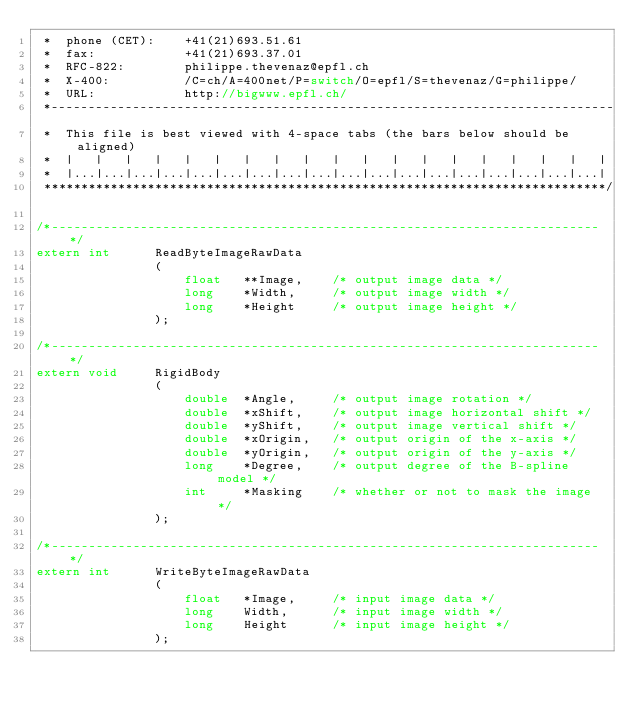Convert code to text. <code><loc_0><loc_0><loc_500><loc_500><_C_> *	phone (CET):	+41(21)693.51.61
 *	fax:			+41(21)693.37.01
 *	RFC-822:		philippe.thevenaz@epfl.ch
 *	X-400:			/C=ch/A=400net/P=switch/O=epfl/S=thevenaz/G=philippe/
 *	URL:			http://bigwww.epfl.ch/
 *----------------------------------------------------------------------------
 *	This file is best viewed with 4-space tabs (the bars below should be aligned)
 *	|	|	|	|	|	|	|	|	|	|	|	|	|	|	|	|	|	|	|
 *  |...|...|...|...|...|...|...|...|...|...|...|...|...|...|...|...|...|...|
 ****************************************************************************/

/*--------------------------------------------------------------------------*/
extern int		ReadByteImageRawData
				(
					float	**Image,	/* output image data */
					long	*Width,		/* output image width */
					long	*Height		/* output image height */
				);

/*--------------------------------------------------------------------------*/
extern void		RigidBody
				(
					double	*Angle,		/* output image rotation */
					double	*xShift,	/* output image horizontal shift */
					double	*yShift,	/* output image vertical shift */
					double	*xOrigin,	/* output origin of the x-axis */
					double	*yOrigin,	/* output origin of the y-axis */
					long	*Degree,	/* output degree of the B-spline model */
					int		*Masking	/* whether or not to mask the image */
				);

/*--------------------------------------------------------------------------*/
extern int		WriteByteImageRawData
				(
					float	*Image,		/* input image data */
					long	Width,		/* input image width */
					long	Height		/* input image height */
				);
</code> 